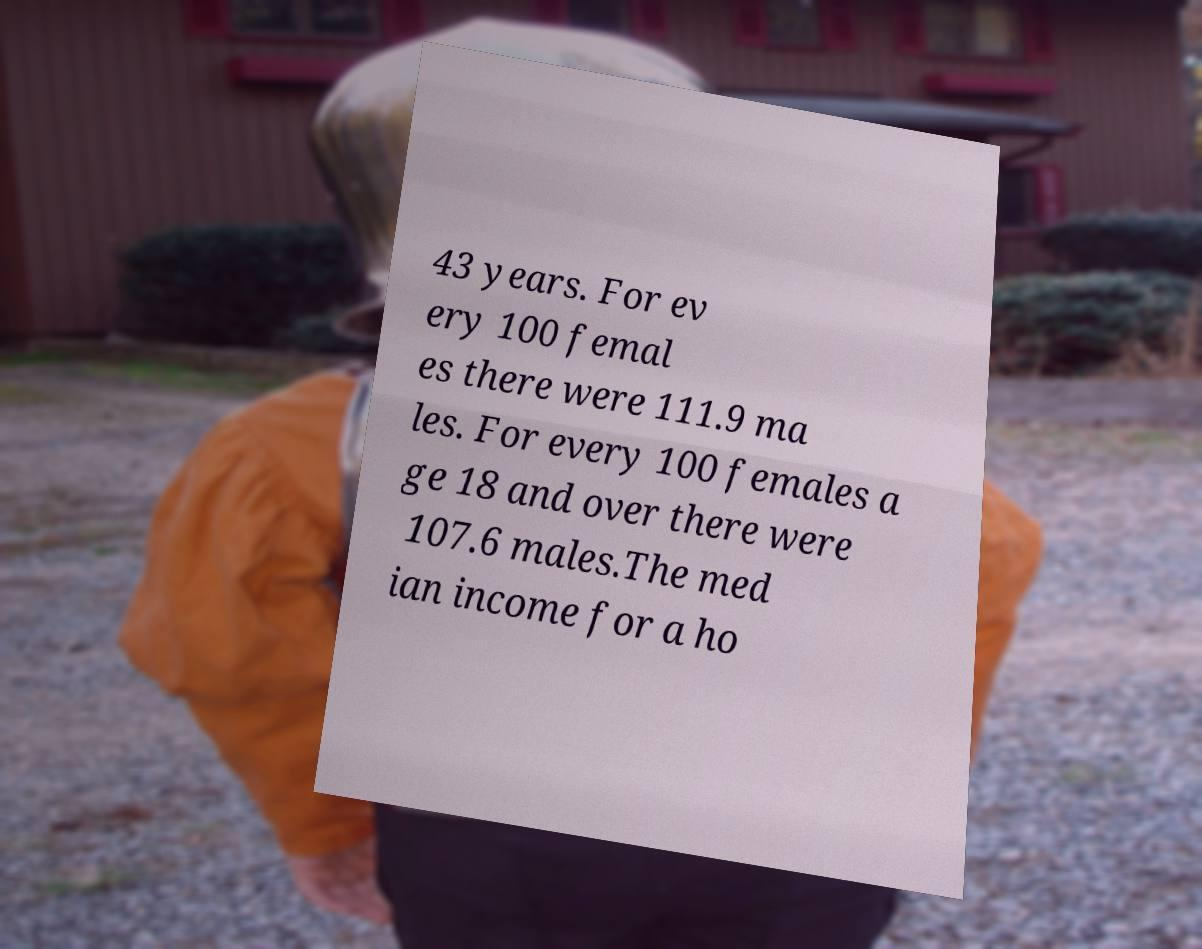What messages or text are displayed in this image? I need them in a readable, typed format. 43 years. For ev ery 100 femal es there were 111.9 ma les. For every 100 females a ge 18 and over there were 107.6 males.The med ian income for a ho 